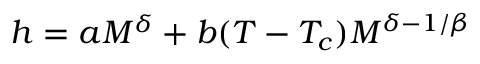Convert formula to latex. <formula><loc_0><loc_0><loc_500><loc_500>h = a M ^ { \delta } + b ( T - T _ { c } ) M ^ { \delta - 1 / \beta }</formula> 